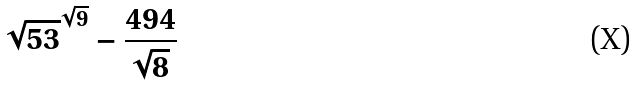Convert formula to latex. <formula><loc_0><loc_0><loc_500><loc_500>\sqrt { 5 3 } ^ { \sqrt { 9 } } - \frac { 4 9 4 } { \sqrt { 8 } }</formula> 